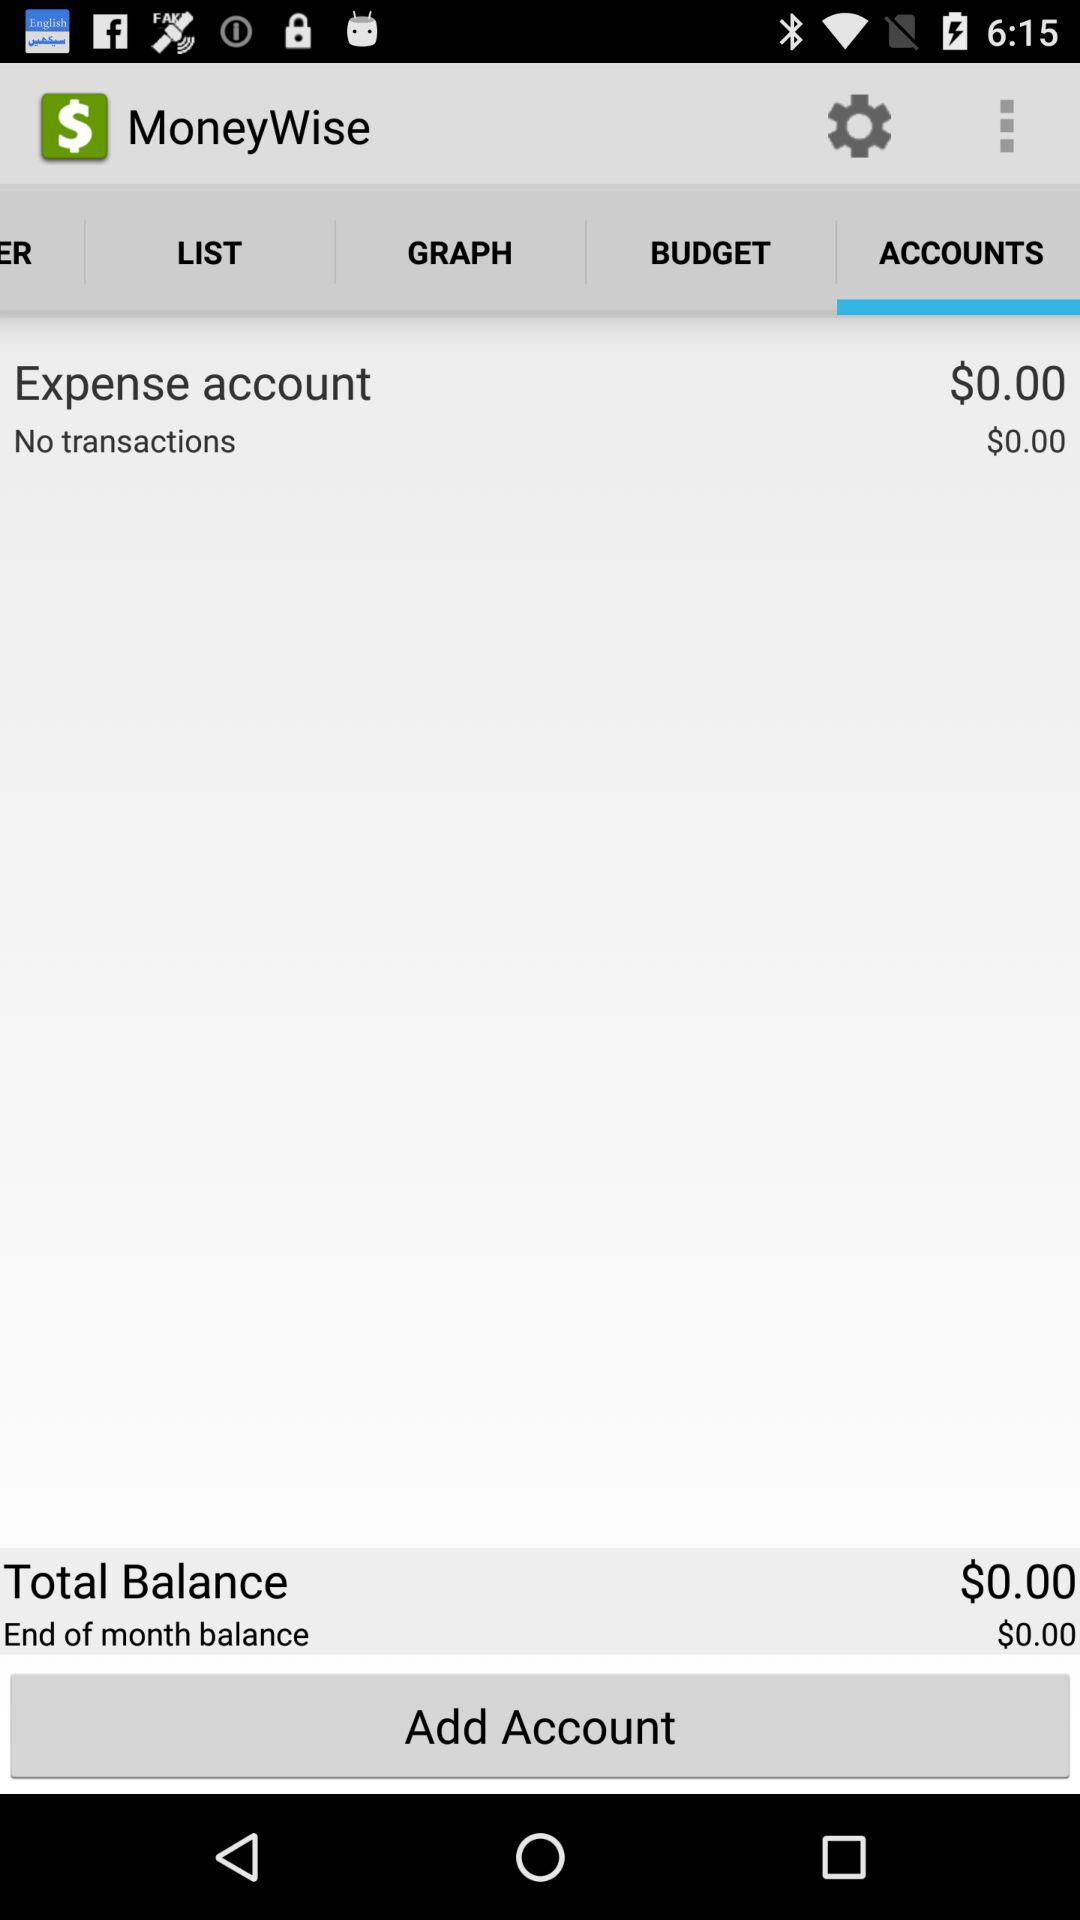What is the balance in the expense account? The balance in the expense account is 0 dollars. 